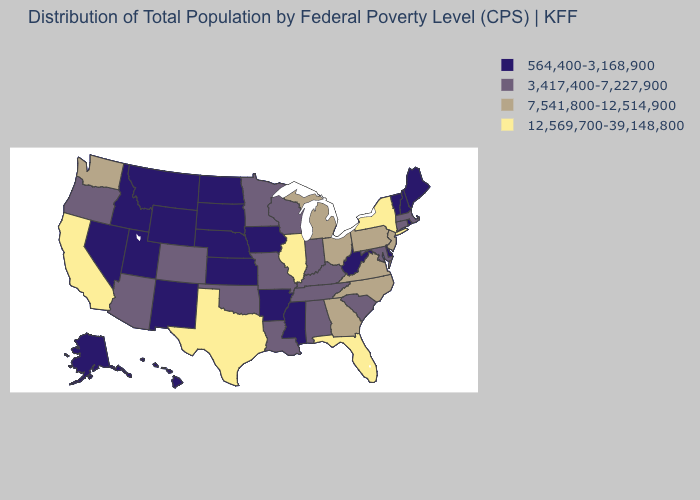Name the states that have a value in the range 7,541,800-12,514,900?
Concise answer only. Georgia, Michigan, New Jersey, North Carolina, Ohio, Pennsylvania, Virginia, Washington. Which states have the highest value in the USA?
Quick response, please. California, Florida, Illinois, New York, Texas. How many symbols are there in the legend?
Short answer required. 4. Name the states that have a value in the range 3,417,400-7,227,900?
Give a very brief answer. Alabama, Arizona, Colorado, Connecticut, Indiana, Kentucky, Louisiana, Maryland, Massachusetts, Minnesota, Missouri, Oklahoma, Oregon, South Carolina, Tennessee, Wisconsin. How many symbols are there in the legend?
Be succinct. 4. Does Wisconsin have the highest value in the MidWest?
Give a very brief answer. No. Does the map have missing data?
Concise answer only. No. Among the states that border Wisconsin , does Iowa have the lowest value?
Give a very brief answer. Yes. What is the highest value in the Northeast ?
Answer briefly. 12,569,700-39,148,800. What is the value of West Virginia?
Answer briefly. 564,400-3,168,900. Which states have the lowest value in the West?
Write a very short answer. Alaska, Hawaii, Idaho, Montana, Nevada, New Mexico, Utah, Wyoming. Does the first symbol in the legend represent the smallest category?
Short answer required. Yes. What is the value of Minnesota?
Write a very short answer. 3,417,400-7,227,900. What is the value of Arkansas?
Short answer required. 564,400-3,168,900. Does New Hampshire have the lowest value in the USA?
Write a very short answer. Yes. 